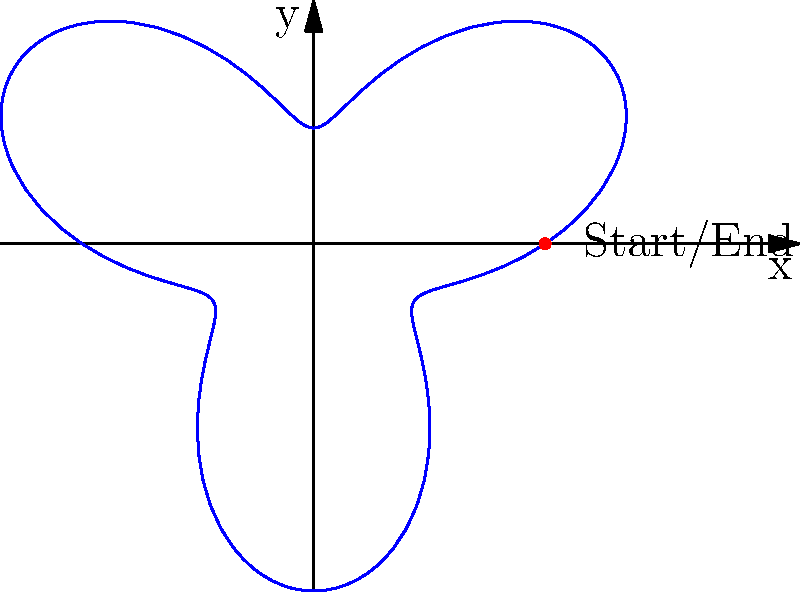In your salsa club, a dancer performs a spinning move where their distance from the center of the dance floor varies periodically. If their trajectory can be modeled by the polar equation $r = 2 + \sin(3\theta)$, where $r$ is in meters, how many complete loops does the dancer make before returning to their starting position? To solve this problem, let's follow these steps:

1) In polar coordinates, a complete revolution occurs when $\theta$ increases by $2\pi$ radians.

2) The dancer returns to their starting position when both $r$ and $\theta$ have the same values as at the beginning.

3) The function $\sin(3\theta)$ has a period of $\frac{2\pi}{3}$. This means it repeats every $\frac{2\pi}{3}$ radians.

4) To find when the dancer returns to the starting position, we need to find the least common multiple (LCM) of $2\pi$ (the full revolution) and $\frac{2\pi}{3}$ (the period of the sine function).

5) The LCM of $2\pi$ and $\frac{2\pi}{3}$ is $2\pi$.

6) This means that after one full revolution ($2\pi$ radians), both $r$ and $\theta$ will have returned to their initial values.

7) During this one revolution, the sine function will have completed 3 full cycles (because $3 * \frac{2\pi}{3} = 2\pi$).

8) Each complete cycle of the sine function corresponds to one loop in the dancer's path.

Therefore, the dancer makes 3 complete loops before returning to their starting position.
Answer: 3 loops 